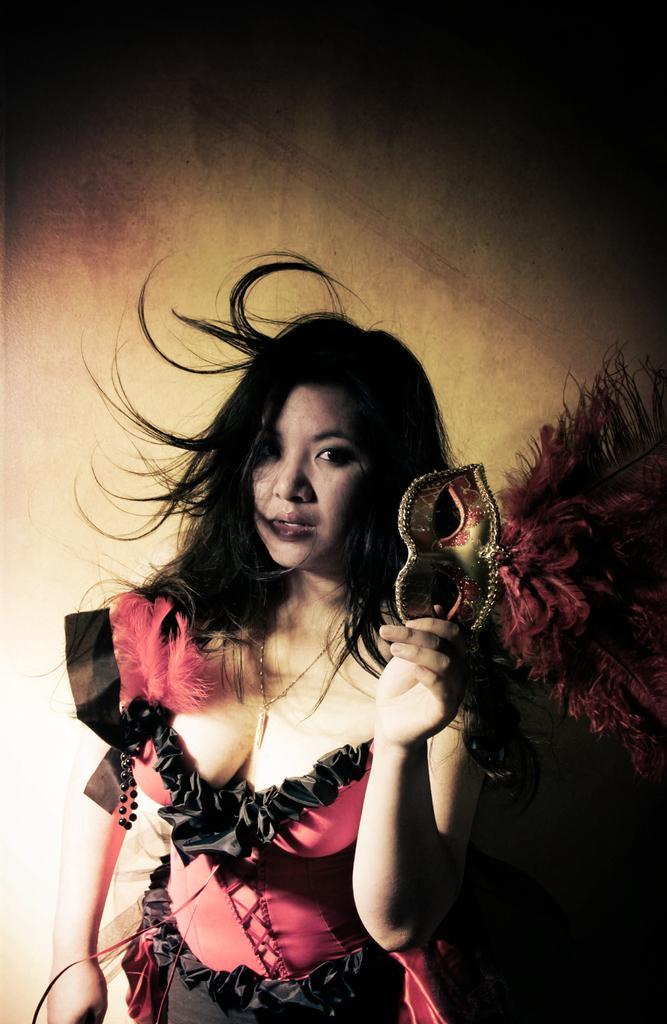Please provide a concise description of this image. In this image we can see a woman standing and holding a mask in her hand. 